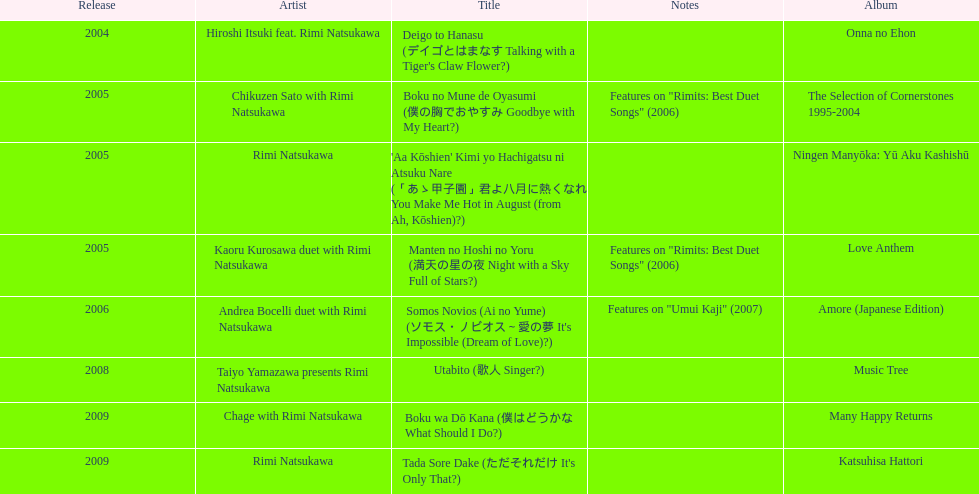Which was released earlier, deigo to hanasu or utabito? Deigo to Hanasu. 